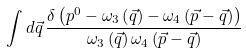Convert formula to latex. <formula><loc_0><loc_0><loc_500><loc_500>\int d \vec { q } \, \frac { \delta \left ( p ^ { 0 } - { \omega } _ { 3 } \left ( \vec { q } \right ) - { \omega } _ { 4 } \left ( \vec { p } - \vec { q } \right ) \right ) } { { \omega } _ { 3 } \left ( \vec { q } \right ) { \omega } _ { 4 } \left ( \vec { p } - \vec { q } \right ) }</formula> 